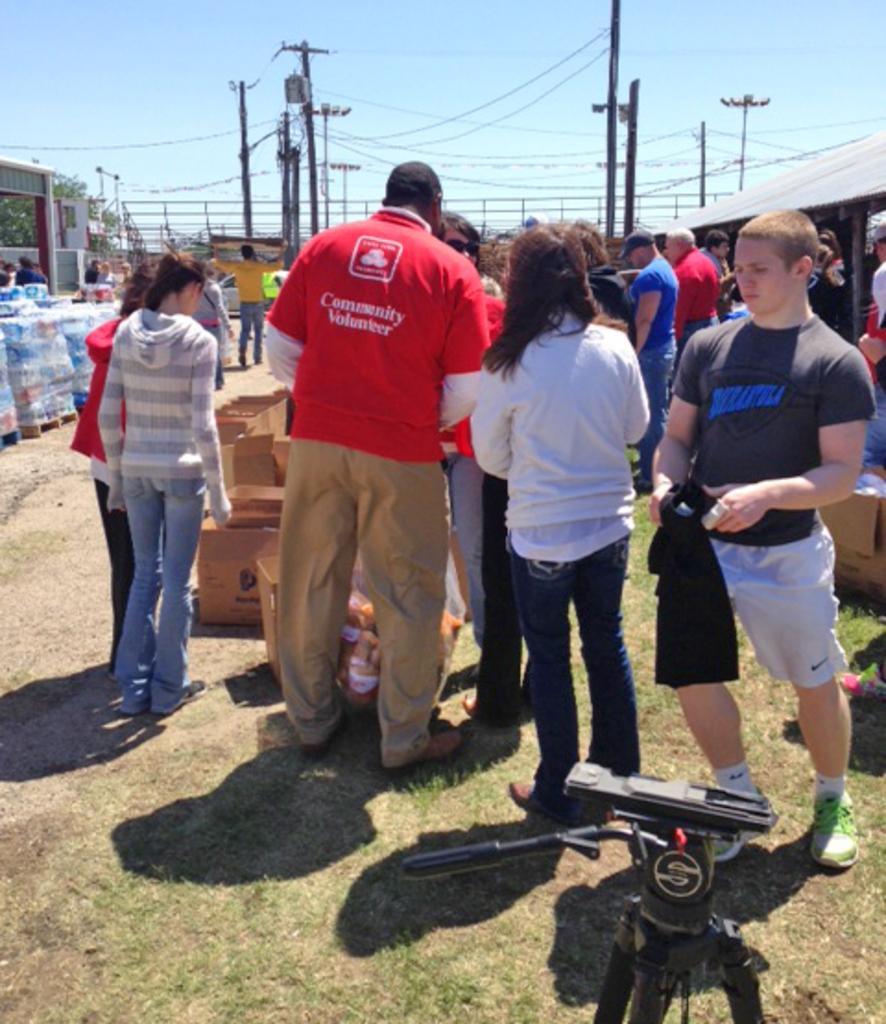In one or two sentences, can you explain what this image depicts? In the center of the image we can see many persons standing on the grass. At the bottom of the image we can see camera stand. In the background we can see poles, tree and sky. 